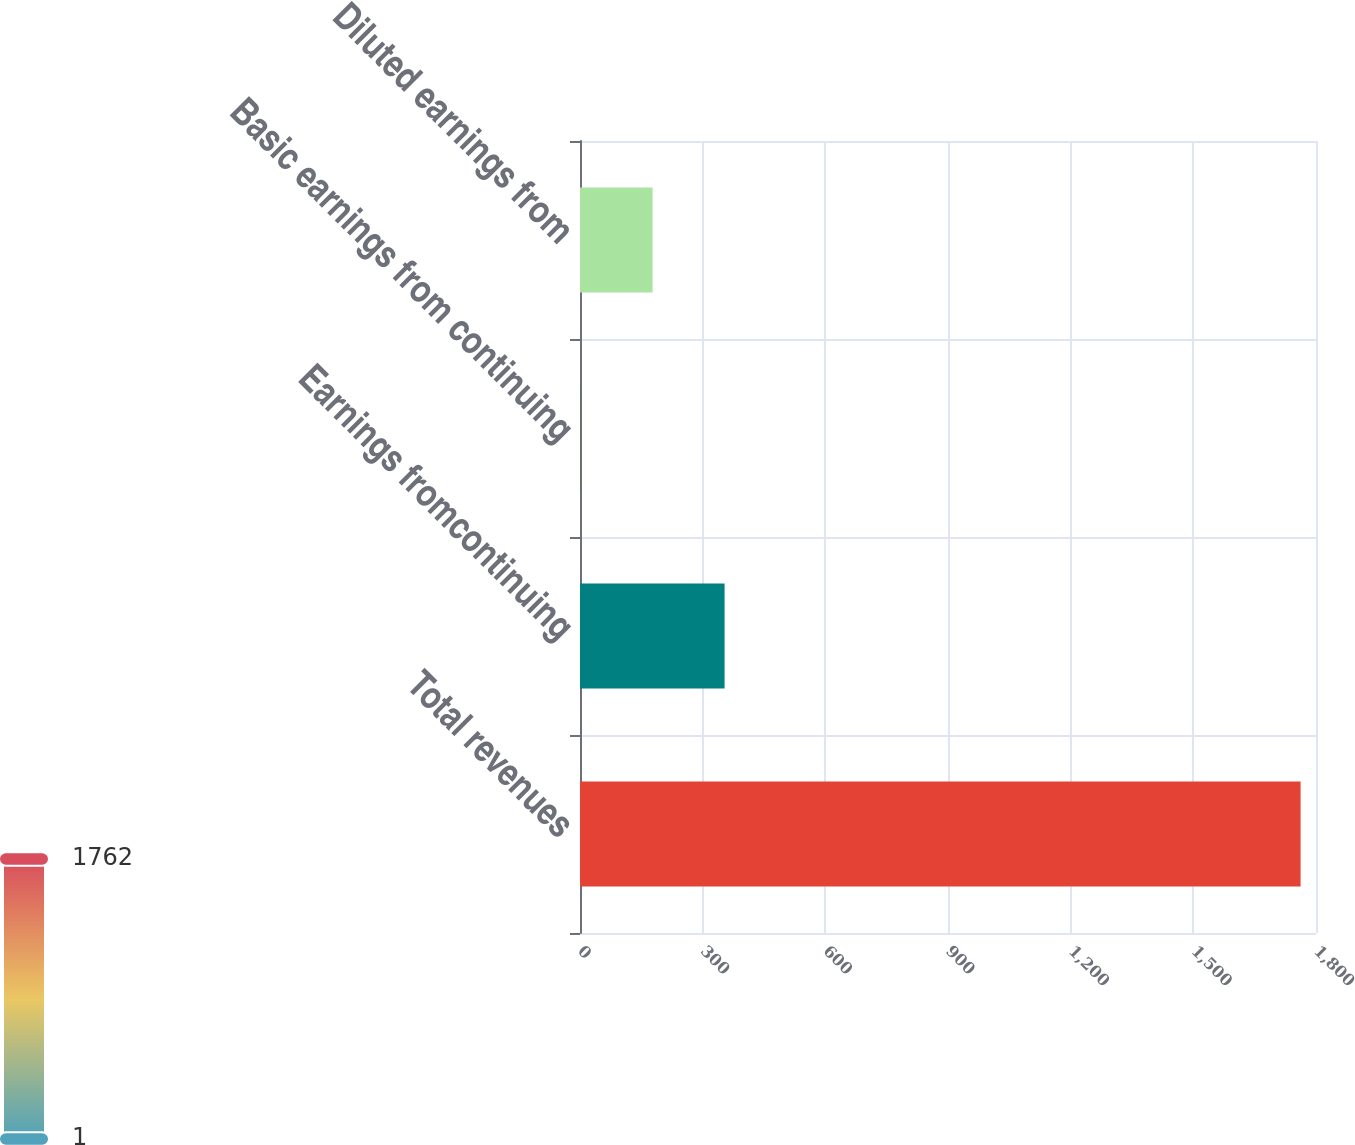<chart> <loc_0><loc_0><loc_500><loc_500><bar_chart><fcel>Total revenues<fcel>Earnings fromcontinuing<fcel>Basic earnings from continuing<fcel>Diluted earnings from<nl><fcel>1762.3<fcel>353.57<fcel>1.39<fcel>177.48<nl></chart> 